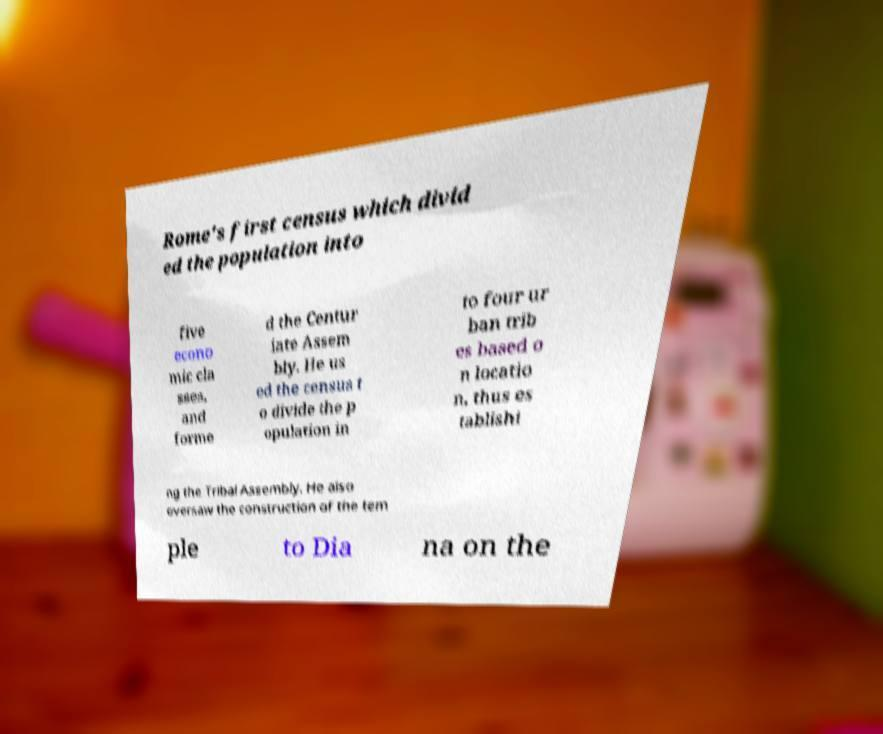Please identify and transcribe the text found in this image. Rome's first census which divid ed the population into five econo mic cla sses, and forme d the Centur iate Assem bly. He us ed the census t o divide the p opulation in to four ur ban trib es based o n locatio n, thus es tablishi ng the Tribal Assembly. He also oversaw the construction of the tem ple to Dia na on the 